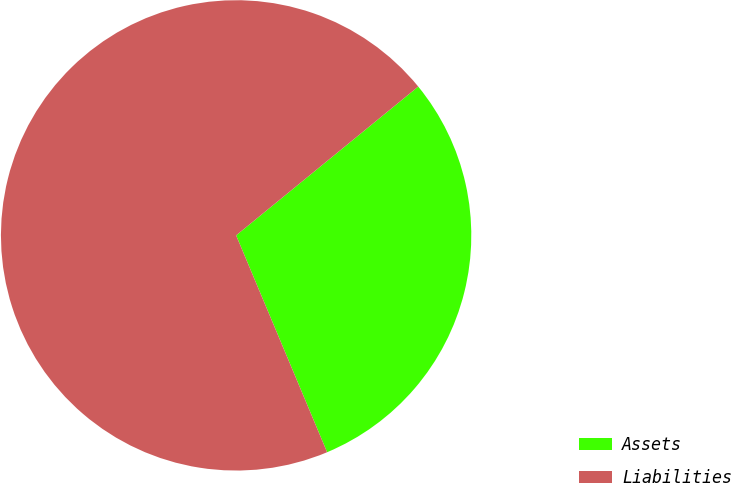<chart> <loc_0><loc_0><loc_500><loc_500><pie_chart><fcel>Assets<fcel>Liabilities<nl><fcel>29.58%<fcel>70.42%<nl></chart> 